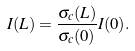<formula> <loc_0><loc_0><loc_500><loc_500>I ( L ) = \frac { \sigma _ { c } ( L ) } { \sigma _ { c } ( 0 ) } I ( 0 ) .</formula> 